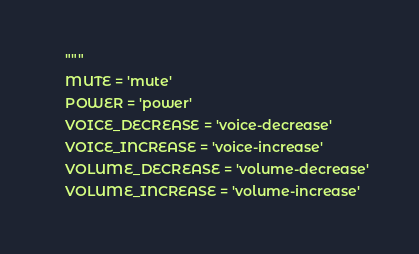Convert code to text. <code><loc_0><loc_0><loc_500><loc_500><_Python_>    """
    MUTE = 'mute'
    POWER = 'power'
    VOICE_DECREASE = 'voice-decrease'
    VOICE_INCREASE = 'voice-increase'
    VOLUME_DECREASE = 'volume-decrease'
    VOLUME_INCREASE = 'volume-increase'

</code> 